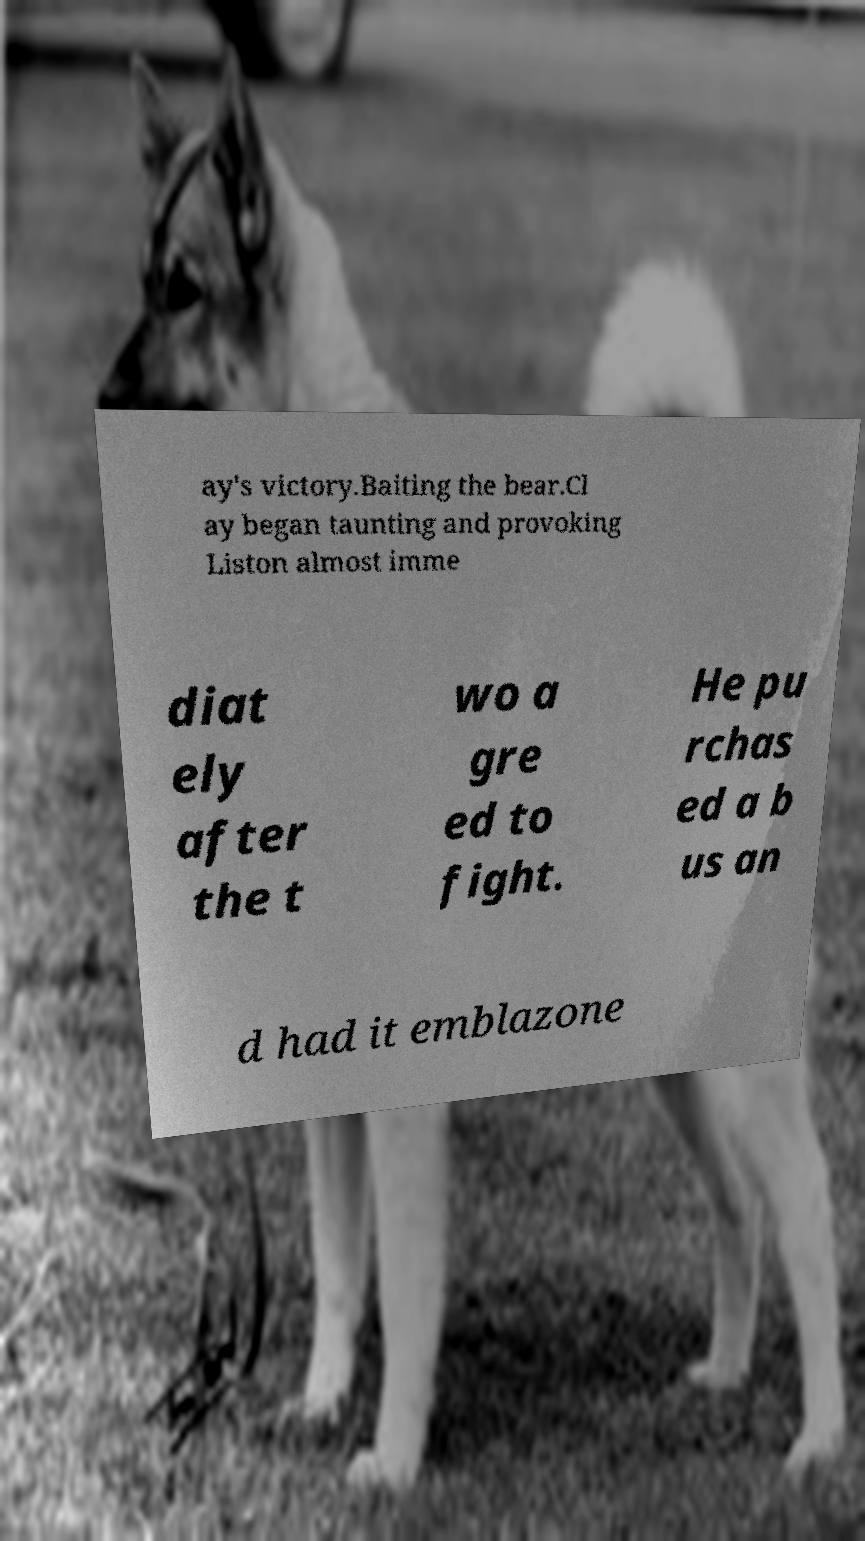For documentation purposes, I need the text within this image transcribed. Could you provide that? ay's victory.Baiting the bear.Cl ay began taunting and provoking Liston almost imme diat ely after the t wo a gre ed to fight. He pu rchas ed a b us an d had it emblazone 